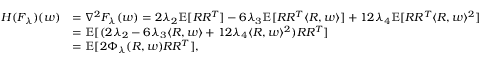Convert formula to latex. <formula><loc_0><loc_0><loc_500><loc_500>\begin{array} { r l } { H ( F _ { \lambda } ) ( w ) } & { = \nabla ^ { 2 } F _ { \lambda } ( w ) = 2 \lambda _ { 2 } \mathbb { E } [ R R ^ { T } ] - 6 \lambda _ { 3 } \mathbb { E } [ R R ^ { T } \langle R , w \rangle ] + 1 2 \lambda _ { 4 } \mathbb { E } [ R R ^ { T } \langle R , w \rangle ^ { 2 } ] } \\ & { = \mathbb { E } [ ( 2 \lambda _ { 2 } - 6 \lambda _ { 3 } \langle R , w \rangle + 1 2 \lambda _ { 4 } \langle R , w \rangle ^ { 2 } ) R R ^ { T } ] } \\ & { = \mathbb { E } [ 2 \Phi _ { \lambda } ( R , w ) R R ^ { T } ] , } \end{array}</formula> 